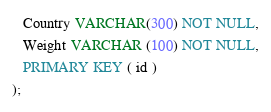Convert code to text. <code><loc_0><loc_0><loc_500><loc_500><_SQL_>   Country VARCHAR(300) NOT NULL,
   Weight VARCHAR (100) NOT NULL,
   PRIMARY KEY ( id )
);
</code> 